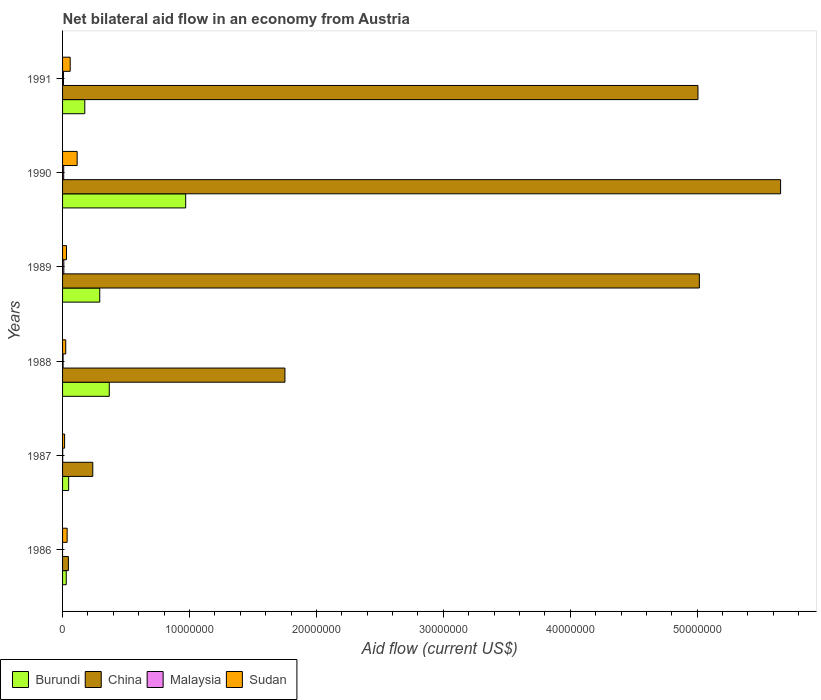How many different coloured bars are there?
Ensure brevity in your answer.  4. How many groups of bars are there?
Provide a short and direct response. 6. Are the number of bars per tick equal to the number of legend labels?
Offer a terse response. No. What is the net bilateral aid flow in Sudan in 1990?
Ensure brevity in your answer.  1.15e+06. Across all years, what is the maximum net bilateral aid flow in Sudan?
Offer a very short reply. 1.15e+06. What is the total net bilateral aid flow in China in the graph?
Provide a short and direct response. 1.77e+08. What is the difference between the net bilateral aid flow in China in 1986 and that in 1988?
Provide a succinct answer. -1.71e+07. What is the difference between the net bilateral aid flow in Sudan in 1987 and the net bilateral aid flow in Burundi in 1989?
Keep it short and to the point. -2.77e+06. What is the average net bilateral aid flow in Malaysia per year?
Keep it short and to the point. 5.17e+04. In the year 1987, what is the difference between the net bilateral aid flow in Burundi and net bilateral aid flow in Malaysia?
Your response must be concise. 4.70e+05. In how many years, is the net bilateral aid flow in China greater than 54000000 US$?
Offer a very short reply. 1. What is the ratio of the net bilateral aid flow in Burundi in 1987 to that in 1989?
Offer a terse response. 0.16. Is the net bilateral aid flow in Malaysia in 1990 less than that in 1991?
Ensure brevity in your answer.  No. Is the difference between the net bilateral aid flow in Burundi in 1987 and 1991 greater than the difference between the net bilateral aid flow in Malaysia in 1987 and 1991?
Give a very brief answer. No. What is the difference between the highest and the second highest net bilateral aid flow in Burundi?
Make the answer very short. 6.02e+06. What is the difference between the highest and the lowest net bilateral aid flow in Sudan?
Offer a terse response. 9.90e+05. In how many years, is the net bilateral aid flow in Malaysia greater than the average net bilateral aid flow in Malaysia taken over all years?
Ensure brevity in your answer.  3. Is it the case that in every year, the sum of the net bilateral aid flow in China and net bilateral aid flow in Sudan is greater than the sum of net bilateral aid flow in Burundi and net bilateral aid flow in Malaysia?
Ensure brevity in your answer.  Yes. Is it the case that in every year, the sum of the net bilateral aid flow in Malaysia and net bilateral aid flow in Burundi is greater than the net bilateral aid flow in Sudan?
Ensure brevity in your answer.  No. How many bars are there?
Ensure brevity in your answer.  23. Does the graph contain any zero values?
Provide a succinct answer. Yes. Where does the legend appear in the graph?
Ensure brevity in your answer.  Bottom left. What is the title of the graph?
Make the answer very short. Net bilateral aid flow in an economy from Austria. What is the label or title of the Y-axis?
Your answer should be very brief. Years. What is the Aid flow (current US$) of Malaysia in 1986?
Ensure brevity in your answer.  0. What is the Aid flow (current US$) in Sudan in 1986?
Make the answer very short. 3.60e+05. What is the Aid flow (current US$) in China in 1987?
Your answer should be compact. 2.38e+06. What is the Aid flow (current US$) in Burundi in 1988?
Make the answer very short. 3.68e+06. What is the Aid flow (current US$) in China in 1988?
Give a very brief answer. 1.75e+07. What is the Aid flow (current US$) of Burundi in 1989?
Ensure brevity in your answer.  2.93e+06. What is the Aid flow (current US$) in China in 1989?
Keep it short and to the point. 5.02e+07. What is the Aid flow (current US$) in Malaysia in 1989?
Provide a succinct answer. 1.00e+05. What is the Aid flow (current US$) in Sudan in 1989?
Provide a short and direct response. 3.10e+05. What is the Aid flow (current US$) in Burundi in 1990?
Offer a terse response. 9.70e+06. What is the Aid flow (current US$) of China in 1990?
Ensure brevity in your answer.  5.66e+07. What is the Aid flow (current US$) of Sudan in 1990?
Make the answer very short. 1.15e+06. What is the Aid flow (current US$) of Burundi in 1991?
Provide a succinct answer. 1.75e+06. What is the Aid flow (current US$) of China in 1991?
Provide a succinct answer. 5.01e+07. What is the Aid flow (current US$) in Malaysia in 1991?
Your answer should be compact. 7.00e+04. Across all years, what is the maximum Aid flow (current US$) of Burundi?
Your answer should be very brief. 9.70e+06. Across all years, what is the maximum Aid flow (current US$) in China?
Your response must be concise. 5.66e+07. Across all years, what is the maximum Aid flow (current US$) in Sudan?
Offer a very short reply. 1.15e+06. Across all years, what is the minimum Aid flow (current US$) of Burundi?
Offer a terse response. 2.90e+05. Across all years, what is the minimum Aid flow (current US$) in China?
Offer a very short reply. 4.60e+05. Across all years, what is the minimum Aid flow (current US$) of Malaysia?
Give a very brief answer. 0. Across all years, what is the minimum Aid flow (current US$) in Sudan?
Provide a succinct answer. 1.60e+05. What is the total Aid flow (current US$) of Burundi in the graph?
Offer a very short reply. 1.88e+07. What is the total Aid flow (current US$) in China in the graph?
Provide a succinct answer. 1.77e+08. What is the total Aid flow (current US$) in Sudan in the graph?
Offer a very short reply. 2.83e+06. What is the difference between the Aid flow (current US$) of China in 1986 and that in 1987?
Offer a terse response. -1.92e+06. What is the difference between the Aid flow (current US$) of Sudan in 1986 and that in 1987?
Offer a terse response. 2.00e+05. What is the difference between the Aid flow (current US$) of Burundi in 1986 and that in 1988?
Your response must be concise. -3.39e+06. What is the difference between the Aid flow (current US$) of China in 1986 and that in 1988?
Keep it short and to the point. -1.71e+07. What is the difference between the Aid flow (current US$) in Burundi in 1986 and that in 1989?
Provide a short and direct response. -2.64e+06. What is the difference between the Aid flow (current US$) of China in 1986 and that in 1989?
Offer a very short reply. -4.97e+07. What is the difference between the Aid flow (current US$) of Sudan in 1986 and that in 1989?
Ensure brevity in your answer.  5.00e+04. What is the difference between the Aid flow (current US$) of Burundi in 1986 and that in 1990?
Offer a terse response. -9.41e+06. What is the difference between the Aid flow (current US$) of China in 1986 and that in 1990?
Offer a very short reply. -5.61e+07. What is the difference between the Aid flow (current US$) of Sudan in 1986 and that in 1990?
Your response must be concise. -7.90e+05. What is the difference between the Aid flow (current US$) in Burundi in 1986 and that in 1991?
Keep it short and to the point. -1.46e+06. What is the difference between the Aid flow (current US$) in China in 1986 and that in 1991?
Your answer should be compact. -4.96e+07. What is the difference between the Aid flow (current US$) of Burundi in 1987 and that in 1988?
Provide a succinct answer. -3.20e+06. What is the difference between the Aid flow (current US$) in China in 1987 and that in 1988?
Your response must be concise. -1.51e+07. What is the difference between the Aid flow (current US$) of Malaysia in 1987 and that in 1988?
Give a very brief answer. -3.00e+04. What is the difference between the Aid flow (current US$) of Burundi in 1987 and that in 1989?
Offer a very short reply. -2.45e+06. What is the difference between the Aid flow (current US$) of China in 1987 and that in 1989?
Keep it short and to the point. -4.78e+07. What is the difference between the Aid flow (current US$) of Malaysia in 1987 and that in 1989?
Your answer should be very brief. -9.00e+04. What is the difference between the Aid flow (current US$) in Burundi in 1987 and that in 1990?
Keep it short and to the point. -9.22e+06. What is the difference between the Aid flow (current US$) in China in 1987 and that in 1990?
Offer a terse response. -5.42e+07. What is the difference between the Aid flow (current US$) in Sudan in 1987 and that in 1990?
Your response must be concise. -9.90e+05. What is the difference between the Aid flow (current US$) of Burundi in 1987 and that in 1991?
Offer a terse response. -1.27e+06. What is the difference between the Aid flow (current US$) in China in 1987 and that in 1991?
Your response must be concise. -4.77e+07. What is the difference between the Aid flow (current US$) in Sudan in 1987 and that in 1991?
Offer a very short reply. -4.40e+05. What is the difference between the Aid flow (current US$) in Burundi in 1988 and that in 1989?
Your answer should be very brief. 7.50e+05. What is the difference between the Aid flow (current US$) of China in 1988 and that in 1989?
Offer a terse response. -3.26e+07. What is the difference between the Aid flow (current US$) of Sudan in 1988 and that in 1989?
Give a very brief answer. -6.00e+04. What is the difference between the Aid flow (current US$) in Burundi in 1988 and that in 1990?
Offer a terse response. -6.02e+06. What is the difference between the Aid flow (current US$) in China in 1988 and that in 1990?
Keep it short and to the point. -3.90e+07. What is the difference between the Aid flow (current US$) in Sudan in 1988 and that in 1990?
Offer a terse response. -9.00e+05. What is the difference between the Aid flow (current US$) in Burundi in 1988 and that in 1991?
Your response must be concise. 1.93e+06. What is the difference between the Aid flow (current US$) of China in 1988 and that in 1991?
Ensure brevity in your answer.  -3.25e+07. What is the difference between the Aid flow (current US$) of Sudan in 1988 and that in 1991?
Offer a very short reply. -3.50e+05. What is the difference between the Aid flow (current US$) of Burundi in 1989 and that in 1990?
Provide a succinct answer. -6.77e+06. What is the difference between the Aid flow (current US$) of China in 1989 and that in 1990?
Give a very brief answer. -6.40e+06. What is the difference between the Aid flow (current US$) of Malaysia in 1989 and that in 1990?
Offer a terse response. 10000. What is the difference between the Aid flow (current US$) in Sudan in 1989 and that in 1990?
Offer a terse response. -8.40e+05. What is the difference between the Aid flow (current US$) of Burundi in 1989 and that in 1991?
Keep it short and to the point. 1.18e+06. What is the difference between the Aid flow (current US$) in Malaysia in 1989 and that in 1991?
Ensure brevity in your answer.  3.00e+04. What is the difference between the Aid flow (current US$) in Burundi in 1990 and that in 1991?
Provide a short and direct response. 7.95e+06. What is the difference between the Aid flow (current US$) of China in 1990 and that in 1991?
Provide a short and direct response. 6.51e+06. What is the difference between the Aid flow (current US$) of Malaysia in 1990 and that in 1991?
Your answer should be very brief. 2.00e+04. What is the difference between the Aid flow (current US$) in Sudan in 1990 and that in 1991?
Give a very brief answer. 5.50e+05. What is the difference between the Aid flow (current US$) in Burundi in 1986 and the Aid flow (current US$) in China in 1987?
Offer a very short reply. -2.09e+06. What is the difference between the Aid flow (current US$) in Burundi in 1986 and the Aid flow (current US$) in Malaysia in 1987?
Offer a very short reply. 2.80e+05. What is the difference between the Aid flow (current US$) in China in 1986 and the Aid flow (current US$) in Malaysia in 1987?
Keep it short and to the point. 4.50e+05. What is the difference between the Aid flow (current US$) in Burundi in 1986 and the Aid flow (current US$) in China in 1988?
Your response must be concise. -1.72e+07. What is the difference between the Aid flow (current US$) in China in 1986 and the Aid flow (current US$) in Malaysia in 1988?
Offer a terse response. 4.20e+05. What is the difference between the Aid flow (current US$) of Burundi in 1986 and the Aid flow (current US$) of China in 1989?
Offer a terse response. -4.99e+07. What is the difference between the Aid flow (current US$) in Burundi in 1986 and the Aid flow (current US$) in Sudan in 1989?
Ensure brevity in your answer.  -2.00e+04. What is the difference between the Aid flow (current US$) in China in 1986 and the Aid flow (current US$) in Malaysia in 1989?
Your answer should be compact. 3.60e+05. What is the difference between the Aid flow (current US$) of Burundi in 1986 and the Aid flow (current US$) of China in 1990?
Offer a terse response. -5.63e+07. What is the difference between the Aid flow (current US$) of Burundi in 1986 and the Aid flow (current US$) of Malaysia in 1990?
Provide a succinct answer. 2.00e+05. What is the difference between the Aid flow (current US$) of Burundi in 1986 and the Aid flow (current US$) of Sudan in 1990?
Your answer should be very brief. -8.60e+05. What is the difference between the Aid flow (current US$) of China in 1986 and the Aid flow (current US$) of Malaysia in 1990?
Ensure brevity in your answer.  3.70e+05. What is the difference between the Aid flow (current US$) of China in 1986 and the Aid flow (current US$) of Sudan in 1990?
Offer a very short reply. -6.90e+05. What is the difference between the Aid flow (current US$) of Burundi in 1986 and the Aid flow (current US$) of China in 1991?
Make the answer very short. -4.98e+07. What is the difference between the Aid flow (current US$) in Burundi in 1986 and the Aid flow (current US$) in Sudan in 1991?
Ensure brevity in your answer.  -3.10e+05. What is the difference between the Aid flow (current US$) of Burundi in 1987 and the Aid flow (current US$) of China in 1988?
Give a very brief answer. -1.70e+07. What is the difference between the Aid flow (current US$) of Burundi in 1987 and the Aid flow (current US$) of Sudan in 1988?
Provide a short and direct response. 2.30e+05. What is the difference between the Aid flow (current US$) in China in 1987 and the Aid flow (current US$) in Malaysia in 1988?
Keep it short and to the point. 2.34e+06. What is the difference between the Aid flow (current US$) in China in 1987 and the Aid flow (current US$) in Sudan in 1988?
Keep it short and to the point. 2.13e+06. What is the difference between the Aid flow (current US$) in Malaysia in 1987 and the Aid flow (current US$) in Sudan in 1988?
Ensure brevity in your answer.  -2.40e+05. What is the difference between the Aid flow (current US$) in Burundi in 1987 and the Aid flow (current US$) in China in 1989?
Give a very brief answer. -4.97e+07. What is the difference between the Aid flow (current US$) in Burundi in 1987 and the Aid flow (current US$) in Malaysia in 1989?
Provide a short and direct response. 3.80e+05. What is the difference between the Aid flow (current US$) of Burundi in 1987 and the Aid flow (current US$) of Sudan in 1989?
Offer a terse response. 1.70e+05. What is the difference between the Aid flow (current US$) in China in 1987 and the Aid flow (current US$) in Malaysia in 1989?
Your answer should be very brief. 2.28e+06. What is the difference between the Aid flow (current US$) of China in 1987 and the Aid flow (current US$) of Sudan in 1989?
Offer a terse response. 2.07e+06. What is the difference between the Aid flow (current US$) of Malaysia in 1987 and the Aid flow (current US$) of Sudan in 1989?
Provide a succinct answer. -3.00e+05. What is the difference between the Aid flow (current US$) of Burundi in 1987 and the Aid flow (current US$) of China in 1990?
Offer a terse response. -5.61e+07. What is the difference between the Aid flow (current US$) in Burundi in 1987 and the Aid flow (current US$) in Sudan in 1990?
Give a very brief answer. -6.70e+05. What is the difference between the Aid flow (current US$) of China in 1987 and the Aid flow (current US$) of Malaysia in 1990?
Your answer should be very brief. 2.29e+06. What is the difference between the Aid flow (current US$) in China in 1987 and the Aid flow (current US$) in Sudan in 1990?
Provide a short and direct response. 1.23e+06. What is the difference between the Aid flow (current US$) in Malaysia in 1987 and the Aid flow (current US$) in Sudan in 1990?
Provide a succinct answer. -1.14e+06. What is the difference between the Aid flow (current US$) of Burundi in 1987 and the Aid flow (current US$) of China in 1991?
Ensure brevity in your answer.  -4.96e+07. What is the difference between the Aid flow (current US$) of China in 1987 and the Aid flow (current US$) of Malaysia in 1991?
Your answer should be very brief. 2.31e+06. What is the difference between the Aid flow (current US$) of China in 1987 and the Aid flow (current US$) of Sudan in 1991?
Provide a succinct answer. 1.78e+06. What is the difference between the Aid flow (current US$) of Malaysia in 1987 and the Aid flow (current US$) of Sudan in 1991?
Keep it short and to the point. -5.90e+05. What is the difference between the Aid flow (current US$) in Burundi in 1988 and the Aid flow (current US$) in China in 1989?
Your response must be concise. -4.65e+07. What is the difference between the Aid flow (current US$) in Burundi in 1988 and the Aid flow (current US$) in Malaysia in 1989?
Make the answer very short. 3.58e+06. What is the difference between the Aid flow (current US$) in Burundi in 1988 and the Aid flow (current US$) in Sudan in 1989?
Your answer should be very brief. 3.37e+06. What is the difference between the Aid flow (current US$) in China in 1988 and the Aid flow (current US$) in Malaysia in 1989?
Keep it short and to the point. 1.74e+07. What is the difference between the Aid flow (current US$) in China in 1988 and the Aid flow (current US$) in Sudan in 1989?
Offer a terse response. 1.72e+07. What is the difference between the Aid flow (current US$) of Burundi in 1988 and the Aid flow (current US$) of China in 1990?
Your response must be concise. -5.29e+07. What is the difference between the Aid flow (current US$) in Burundi in 1988 and the Aid flow (current US$) in Malaysia in 1990?
Give a very brief answer. 3.59e+06. What is the difference between the Aid flow (current US$) in Burundi in 1988 and the Aid flow (current US$) in Sudan in 1990?
Ensure brevity in your answer.  2.53e+06. What is the difference between the Aid flow (current US$) in China in 1988 and the Aid flow (current US$) in Malaysia in 1990?
Provide a short and direct response. 1.74e+07. What is the difference between the Aid flow (current US$) in China in 1988 and the Aid flow (current US$) in Sudan in 1990?
Offer a terse response. 1.64e+07. What is the difference between the Aid flow (current US$) of Malaysia in 1988 and the Aid flow (current US$) of Sudan in 1990?
Keep it short and to the point. -1.11e+06. What is the difference between the Aid flow (current US$) in Burundi in 1988 and the Aid flow (current US$) in China in 1991?
Give a very brief answer. -4.64e+07. What is the difference between the Aid flow (current US$) of Burundi in 1988 and the Aid flow (current US$) of Malaysia in 1991?
Give a very brief answer. 3.61e+06. What is the difference between the Aid flow (current US$) in Burundi in 1988 and the Aid flow (current US$) in Sudan in 1991?
Give a very brief answer. 3.08e+06. What is the difference between the Aid flow (current US$) of China in 1988 and the Aid flow (current US$) of Malaysia in 1991?
Offer a very short reply. 1.74e+07. What is the difference between the Aid flow (current US$) of China in 1988 and the Aid flow (current US$) of Sudan in 1991?
Your answer should be compact. 1.69e+07. What is the difference between the Aid flow (current US$) in Malaysia in 1988 and the Aid flow (current US$) in Sudan in 1991?
Provide a short and direct response. -5.60e+05. What is the difference between the Aid flow (current US$) in Burundi in 1989 and the Aid flow (current US$) in China in 1990?
Provide a succinct answer. -5.36e+07. What is the difference between the Aid flow (current US$) in Burundi in 1989 and the Aid flow (current US$) in Malaysia in 1990?
Provide a short and direct response. 2.84e+06. What is the difference between the Aid flow (current US$) of Burundi in 1989 and the Aid flow (current US$) of Sudan in 1990?
Ensure brevity in your answer.  1.78e+06. What is the difference between the Aid flow (current US$) in China in 1989 and the Aid flow (current US$) in Malaysia in 1990?
Offer a terse response. 5.01e+07. What is the difference between the Aid flow (current US$) in China in 1989 and the Aid flow (current US$) in Sudan in 1990?
Give a very brief answer. 4.90e+07. What is the difference between the Aid flow (current US$) in Malaysia in 1989 and the Aid flow (current US$) in Sudan in 1990?
Your answer should be very brief. -1.05e+06. What is the difference between the Aid flow (current US$) in Burundi in 1989 and the Aid flow (current US$) in China in 1991?
Keep it short and to the point. -4.71e+07. What is the difference between the Aid flow (current US$) in Burundi in 1989 and the Aid flow (current US$) in Malaysia in 1991?
Your answer should be very brief. 2.86e+06. What is the difference between the Aid flow (current US$) in Burundi in 1989 and the Aid flow (current US$) in Sudan in 1991?
Your answer should be very brief. 2.33e+06. What is the difference between the Aid flow (current US$) in China in 1989 and the Aid flow (current US$) in Malaysia in 1991?
Offer a very short reply. 5.01e+07. What is the difference between the Aid flow (current US$) in China in 1989 and the Aid flow (current US$) in Sudan in 1991?
Ensure brevity in your answer.  4.96e+07. What is the difference between the Aid flow (current US$) in Malaysia in 1989 and the Aid flow (current US$) in Sudan in 1991?
Offer a terse response. -5.00e+05. What is the difference between the Aid flow (current US$) in Burundi in 1990 and the Aid flow (current US$) in China in 1991?
Give a very brief answer. -4.04e+07. What is the difference between the Aid flow (current US$) of Burundi in 1990 and the Aid flow (current US$) of Malaysia in 1991?
Provide a succinct answer. 9.63e+06. What is the difference between the Aid flow (current US$) in Burundi in 1990 and the Aid flow (current US$) in Sudan in 1991?
Your response must be concise. 9.10e+06. What is the difference between the Aid flow (current US$) in China in 1990 and the Aid flow (current US$) in Malaysia in 1991?
Provide a short and direct response. 5.65e+07. What is the difference between the Aid flow (current US$) in China in 1990 and the Aid flow (current US$) in Sudan in 1991?
Give a very brief answer. 5.60e+07. What is the difference between the Aid flow (current US$) of Malaysia in 1990 and the Aid flow (current US$) of Sudan in 1991?
Your answer should be very brief. -5.10e+05. What is the average Aid flow (current US$) of Burundi per year?
Provide a short and direct response. 3.14e+06. What is the average Aid flow (current US$) of China per year?
Keep it short and to the point. 2.95e+07. What is the average Aid flow (current US$) of Malaysia per year?
Provide a succinct answer. 5.17e+04. What is the average Aid flow (current US$) of Sudan per year?
Your answer should be compact. 4.72e+05. In the year 1986, what is the difference between the Aid flow (current US$) of Burundi and Aid flow (current US$) of China?
Your response must be concise. -1.70e+05. In the year 1986, what is the difference between the Aid flow (current US$) of Burundi and Aid flow (current US$) of Sudan?
Make the answer very short. -7.00e+04. In the year 1987, what is the difference between the Aid flow (current US$) in Burundi and Aid flow (current US$) in China?
Make the answer very short. -1.90e+06. In the year 1987, what is the difference between the Aid flow (current US$) in China and Aid flow (current US$) in Malaysia?
Offer a very short reply. 2.37e+06. In the year 1987, what is the difference between the Aid flow (current US$) of China and Aid flow (current US$) of Sudan?
Make the answer very short. 2.22e+06. In the year 1988, what is the difference between the Aid flow (current US$) in Burundi and Aid flow (current US$) in China?
Ensure brevity in your answer.  -1.38e+07. In the year 1988, what is the difference between the Aid flow (current US$) in Burundi and Aid flow (current US$) in Malaysia?
Provide a short and direct response. 3.64e+06. In the year 1988, what is the difference between the Aid flow (current US$) of Burundi and Aid flow (current US$) of Sudan?
Ensure brevity in your answer.  3.43e+06. In the year 1988, what is the difference between the Aid flow (current US$) of China and Aid flow (current US$) of Malaysia?
Give a very brief answer. 1.75e+07. In the year 1988, what is the difference between the Aid flow (current US$) in China and Aid flow (current US$) in Sudan?
Keep it short and to the point. 1.73e+07. In the year 1988, what is the difference between the Aid flow (current US$) in Malaysia and Aid flow (current US$) in Sudan?
Provide a short and direct response. -2.10e+05. In the year 1989, what is the difference between the Aid flow (current US$) of Burundi and Aid flow (current US$) of China?
Provide a short and direct response. -4.72e+07. In the year 1989, what is the difference between the Aid flow (current US$) of Burundi and Aid flow (current US$) of Malaysia?
Offer a very short reply. 2.83e+06. In the year 1989, what is the difference between the Aid flow (current US$) in Burundi and Aid flow (current US$) in Sudan?
Your response must be concise. 2.62e+06. In the year 1989, what is the difference between the Aid flow (current US$) in China and Aid flow (current US$) in Malaysia?
Your response must be concise. 5.01e+07. In the year 1989, what is the difference between the Aid flow (current US$) in China and Aid flow (current US$) in Sudan?
Offer a very short reply. 4.99e+07. In the year 1989, what is the difference between the Aid flow (current US$) in Malaysia and Aid flow (current US$) in Sudan?
Offer a terse response. -2.10e+05. In the year 1990, what is the difference between the Aid flow (current US$) in Burundi and Aid flow (current US$) in China?
Ensure brevity in your answer.  -4.69e+07. In the year 1990, what is the difference between the Aid flow (current US$) in Burundi and Aid flow (current US$) in Malaysia?
Ensure brevity in your answer.  9.61e+06. In the year 1990, what is the difference between the Aid flow (current US$) in Burundi and Aid flow (current US$) in Sudan?
Give a very brief answer. 8.55e+06. In the year 1990, what is the difference between the Aid flow (current US$) of China and Aid flow (current US$) of Malaysia?
Your response must be concise. 5.65e+07. In the year 1990, what is the difference between the Aid flow (current US$) in China and Aid flow (current US$) in Sudan?
Your response must be concise. 5.54e+07. In the year 1990, what is the difference between the Aid flow (current US$) in Malaysia and Aid flow (current US$) in Sudan?
Offer a terse response. -1.06e+06. In the year 1991, what is the difference between the Aid flow (current US$) in Burundi and Aid flow (current US$) in China?
Your answer should be very brief. -4.83e+07. In the year 1991, what is the difference between the Aid flow (current US$) in Burundi and Aid flow (current US$) in Malaysia?
Your answer should be very brief. 1.68e+06. In the year 1991, what is the difference between the Aid flow (current US$) in Burundi and Aid flow (current US$) in Sudan?
Your answer should be very brief. 1.15e+06. In the year 1991, what is the difference between the Aid flow (current US$) of China and Aid flow (current US$) of Malaysia?
Make the answer very short. 5.00e+07. In the year 1991, what is the difference between the Aid flow (current US$) in China and Aid flow (current US$) in Sudan?
Give a very brief answer. 4.95e+07. In the year 1991, what is the difference between the Aid flow (current US$) in Malaysia and Aid flow (current US$) in Sudan?
Your answer should be very brief. -5.30e+05. What is the ratio of the Aid flow (current US$) of Burundi in 1986 to that in 1987?
Offer a terse response. 0.6. What is the ratio of the Aid flow (current US$) in China in 1986 to that in 1987?
Make the answer very short. 0.19. What is the ratio of the Aid flow (current US$) in Sudan in 1986 to that in 1987?
Your answer should be very brief. 2.25. What is the ratio of the Aid flow (current US$) of Burundi in 1986 to that in 1988?
Provide a short and direct response. 0.08. What is the ratio of the Aid flow (current US$) in China in 1986 to that in 1988?
Ensure brevity in your answer.  0.03. What is the ratio of the Aid flow (current US$) of Sudan in 1986 to that in 1988?
Offer a terse response. 1.44. What is the ratio of the Aid flow (current US$) of Burundi in 1986 to that in 1989?
Keep it short and to the point. 0.1. What is the ratio of the Aid flow (current US$) of China in 1986 to that in 1989?
Keep it short and to the point. 0.01. What is the ratio of the Aid flow (current US$) in Sudan in 1986 to that in 1989?
Give a very brief answer. 1.16. What is the ratio of the Aid flow (current US$) in Burundi in 1986 to that in 1990?
Your answer should be compact. 0.03. What is the ratio of the Aid flow (current US$) in China in 1986 to that in 1990?
Your response must be concise. 0.01. What is the ratio of the Aid flow (current US$) in Sudan in 1986 to that in 1990?
Your answer should be very brief. 0.31. What is the ratio of the Aid flow (current US$) of Burundi in 1986 to that in 1991?
Your answer should be compact. 0.17. What is the ratio of the Aid flow (current US$) of China in 1986 to that in 1991?
Ensure brevity in your answer.  0.01. What is the ratio of the Aid flow (current US$) in Sudan in 1986 to that in 1991?
Offer a very short reply. 0.6. What is the ratio of the Aid flow (current US$) of Burundi in 1987 to that in 1988?
Your response must be concise. 0.13. What is the ratio of the Aid flow (current US$) of China in 1987 to that in 1988?
Your response must be concise. 0.14. What is the ratio of the Aid flow (current US$) in Sudan in 1987 to that in 1988?
Ensure brevity in your answer.  0.64. What is the ratio of the Aid flow (current US$) in Burundi in 1987 to that in 1989?
Offer a very short reply. 0.16. What is the ratio of the Aid flow (current US$) of China in 1987 to that in 1989?
Your answer should be compact. 0.05. What is the ratio of the Aid flow (current US$) of Malaysia in 1987 to that in 1989?
Make the answer very short. 0.1. What is the ratio of the Aid flow (current US$) in Sudan in 1987 to that in 1989?
Give a very brief answer. 0.52. What is the ratio of the Aid flow (current US$) of Burundi in 1987 to that in 1990?
Your answer should be very brief. 0.05. What is the ratio of the Aid flow (current US$) of China in 1987 to that in 1990?
Your answer should be very brief. 0.04. What is the ratio of the Aid flow (current US$) of Malaysia in 1987 to that in 1990?
Provide a short and direct response. 0.11. What is the ratio of the Aid flow (current US$) of Sudan in 1987 to that in 1990?
Provide a succinct answer. 0.14. What is the ratio of the Aid flow (current US$) of Burundi in 1987 to that in 1991?
Your answer should be very brief. 0.27. What is the ratio of the Aid flow (current US$) of China in 1987 to that in 1991?
Provide a succinct answer. 0.05. What is the ratio of the Aid flow (current US$) in Malaysia in 1987 to that in 1991?
Your answer should be compact. 0.14. What is the ratio of the Aid flow (current US$) in Sudan in 1987 to that in 1991?
Keep it short and to the point. 0.27. What is the ratio of the Aid flow (current US$) in Burundi in 1988 to that in 1989?
Offer a very short reply. 1.26. What is the ratio of the Aid flow (current US$) in China in 1988 to that in 1989?
Offer a terse response. 0.35. What is the ratio of the Aid flow (current US$) of Sudan in 1988 to that in 1989?
Provide a short and direct response. 0.81. What is the ratio of the Aid flow (current US$) in Burundi in 1988 to that in 1990?
Give a very brief answer. 0.38. What is the ratio of the Aid flow (current US$) in China in 1988 to that in 1990?
Make the answer very short. 0.31. What is the ratio of the Aid flow (current US$) of Malaysia in 1988 to that in 1990?
Make the answer very short. 0.44. What is the ratio of the Aid flow (current US$) in Sudan in 1988 to that in 1990?
Provide a succinct answer. 0.22. What is the ratio of the Aid flow (current US$) in Burundi in 1988 to that in 1991?
Make the answer very short. 2.1. What is the ratio of the Aid flow (current US$) of China in 1988 to that in 1991?
Make the answer very short. 0.35. What is the ratio of the Aid flow (current US$) of Malaysia in 1988 to that in 1991?
Offer a terse response. 0.57. What is the ratio of the Aid flow (current US$) in Sudan in 1988 to that in 1991?
Make the answer very short. 0.42. What is the ratio of the Aid flow (current US$) in Burundi in 1989 to that in 1990?
Give a very brief answer. 0.3. What is the ratio of the Aid flow (current US$) of China in 1989 to that in 1990?
Your answer should be very brief. 0.89. What is the ratio of the Aid flow (current US$) in Malaysia in 1989 to that in 1990?
Ensure brevity in your answer.  1.11. What is the ratio of the Aid flow (current US$) of Sudan in 1989 to that in 1990?
Offer a terse response. 0.27. What is the ratio of the Aid flow (current US$) in Burundi in 1989 to that in 1991?
Ensure brevity in your answer.  1.67. What is the ratio of the Aid flow (current US$) in Malaysia in 1989 to that in 1991?
Your answer should be compact. 1.43. What is the ratio of the Aid flow (current US$) in Sudan in 1989 to that in 1991?
Give a very brief answer. 0.52. What is the ratio of the Aid flow (current US$) in Burundi in 1990 to that in 1991?
Provide a succinct answer. 5.54. What is the ratio of the Aid flow (current US$) of China in 1990 to that in 1991?
Make the answer very short. 1.13. What is the ratio of the Aid flow (current US$) of Malaysia in 1990 to that in 1991?
Offer a terse response. 1.29. What is the ratio of the Aid flow (current US$) of Sudan in 1990 to that in 1991?
Ensure brevity in your answer.  1.92. What is the difference between the highest and the second highest Aid flow (current US$) of Burundi?
Your answer should be very brief. 6.02e+06. What is the difference between the highest and the second highest Aid flow (current US$) in China?
Ensure brevity in your answer.  6.40e+06. What is the difference between the highest and the second highest Aid flow (current US$) of Sudan?
Your response must be concise. 5.50e+05. What is the difference between the highest and the lowest Aid flow (current US$) of Burundi?
Make the answer very short. 9.41e+06. What is the difference between the highest and the lowest Aid flow (current US$) of China?
Make the answer very short. 5.61e+07. What is the difference between the highest and the lowest Aid flow (current US$) of Sudan?
Make the answer very short. 9.90e+05. 